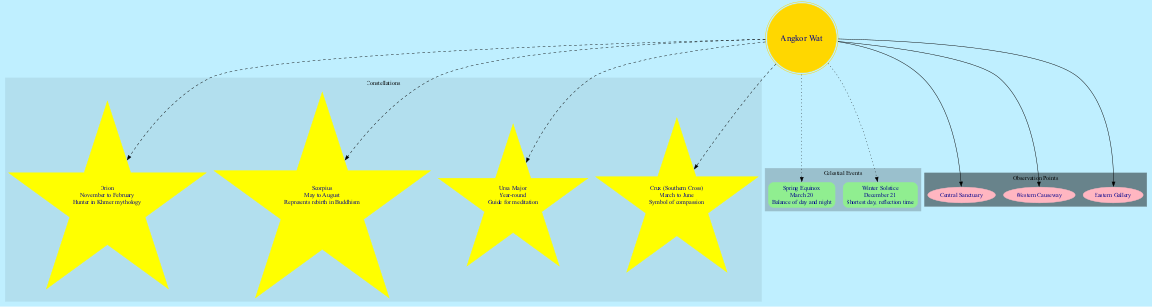What constellations are visible from Angkor Wat in the winter? Orion is visible from November to February, which falls in the winter months. I reference the constellation visibility section in the diagram.
Answer: Orion How many celestial events are depicted in the diagram? The diagram includes two celestial events: Spring Equinox and Winter Solstice. Counting these events shows there are two in total.
Answer: 2 Which constellation represents rebirth in Buddhism? The diagram indicates Scorpius as the constellation representing rebirth in Buddhism, as noted in its significance.
Answer: Scorpius What is the date of the Winter Solstice? According to the celestial events section of the diagram, the Winter Solstice occurs on December 21. I locate the event and find its date.
Answer: December 21 How many observation points are there around Angkor Wat? The diagram displays three observation points: Central Sanctuary, Western Causeway, and Eastern Gallery. Counting these provides the total number of observation points.
Answer: 3 Which constellation is visible year-round? The diagram specifies Ursa Major as the constellation that is visible throughout the entire year. I cross-reference the visibility information for clarity.
Answer: Ursa Major What is the significance of the Southern Cross? The significance of the Southern Cross is noted as a symbol of compassion in the diagram's constellation section. I refer to the significance details for accurate information.
Answer: Symbol of compassion Which constellation is linked to Khmer mythology? Orion is described as the Hunter in Khmer mythology according to the diagram's information on the constellations. This ties the constellation to its cultural significance.
Answer: Orion What is the primary observation point at Angkor Wat? The diagram lists several observation points, but the Central Sanctuary is typically considered the primary observation point for celestial observations. I refer to the observation points section for verification.
Answer: Central Sanctuary 